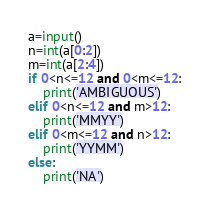Convert code to text. <code><loc_0><loc_0><loc_500><loc_500><_Python_>a=input()
n=int(a[0:2])
m=int(a[2:4])
if 0<n<=12 and 0<m<=12:
    print('AMBIGUOUS')
elif 0<n<=12 and m>12:
    print('MMYY')
elif 0<m<=12 and n>12:
    print('YYMM')
else:
    print('NA')</code> 